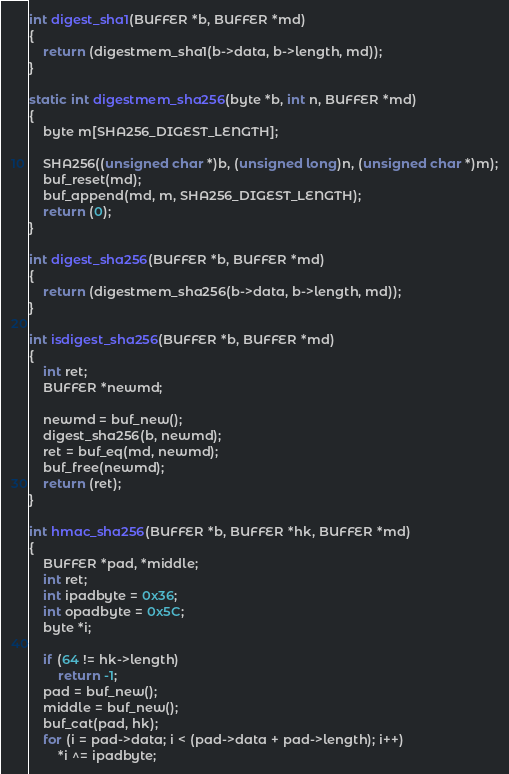<code> <loc_0><loc_0><loc_500><loc_500><_C_>
int digest_sha1(BUFFER *b, BUFFER *md)
{
	return (digestmem_sha1(b->data, b->length, md));
}

static int digestmem_sha256(byte *b, int n, BUFFER *md)
{
	byte m[SHA256_DIGEST_LENGTH];

	SHA256((unsigned char *)b, (unsigned long)n, (unsigned char *)m);
	buf_reset(md);
	buf_append(md, m, SHA256_DIGEST_LENGTH);
	return (0);
}

int digest_sha256(BUFFER *b, BUFFER *md)
{
	return (digestmem_sha256(b->data, b->length, md));
}

int isdigest_sha256(BUFFER *b, BUFFER *md)
{
	int ret;
	BUFFER *newmd;

	newmd = buf_new();
	digest_sha256(b, newmd);
	ret = buf_eq(md, newmd);
	buf_free(newmd);
	return (ret);
}

int hmac_sha256(BUFFER *b, BUFFER *hk, BUFFER *md)
{
	BUFFER *pad, *middle;
	int ret;
	int ipadbyte = 0x36;
	int opadbyte = 0x5C;
	byte *i;

	if (64 != hk->length)
		return -1;
	pad = buf_new();
	middle = buf_new();
	buf_cat(pad, hk);
	for (i = pad->data; i < (pad->data + pad->length); i++)
		*i ^= ipadbyte;</code> 